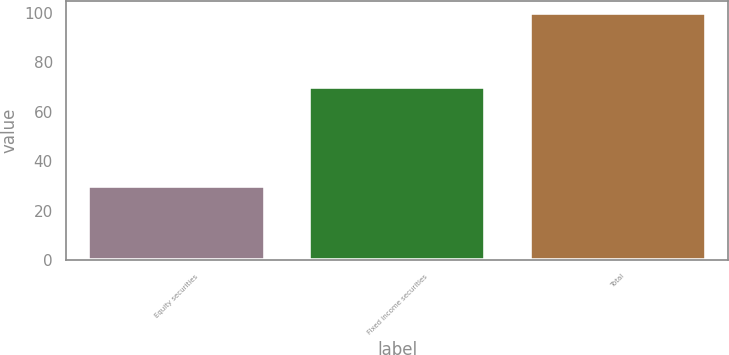Convert chart. <chart><loc_0><loc_0><loc_500><loc_500><bar_chart><fcel>Equity securities<fcel>Fixed income securities<fcel>Total<nl><fcel>30<fcel>70<fcel>100<nl></chart> 